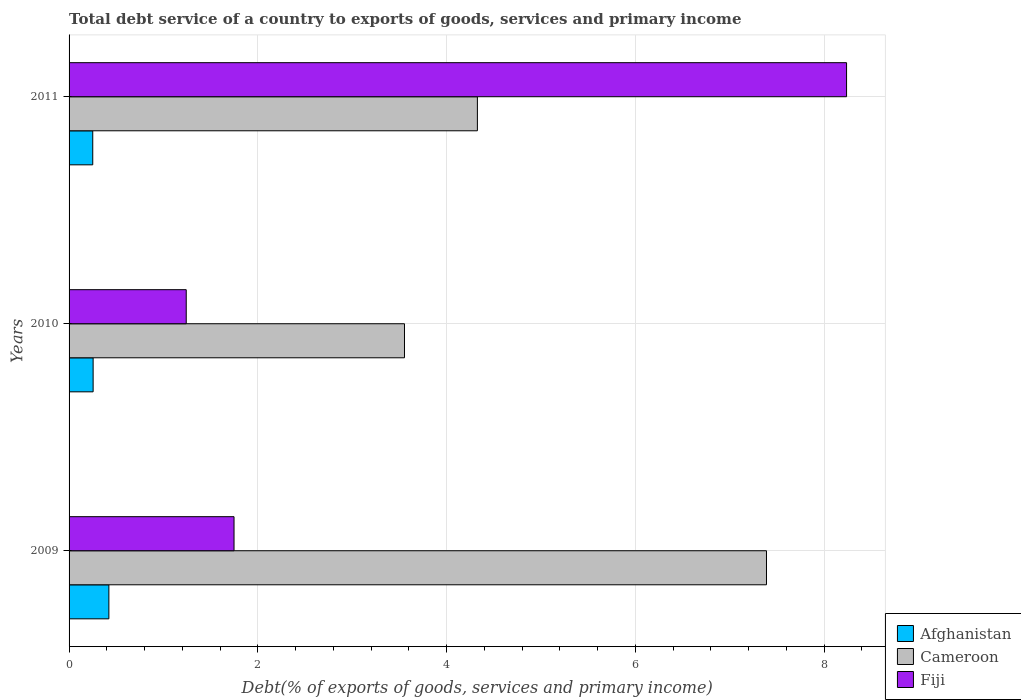How many different coloured bars are there?
Give a very brief answer. 3. Are the number of bars on each tick of the Y-axis equal?
Offer a very short reply. Yes. How many bars are there on the 3rd tick from the top?
Offer a terse response. 3. How many bars are there on the 2nd tick from the bottom?
Keep it short and to the point. 3. In how many cases, is the number of bars for a given year not equal to the number of legend labels?
Provide a succinct answer. 0. What is the total debt service in Fiji in 2009?
Make the answer very short. 1.75. Across all years, what is the maximum total debt service in Afghanistan?
Provide a short and direct response. 0.42. Across all years, what is the minimum total debt service in Fiji?
Give a very brief answer. 1.24. In which year was the total debt service in Cameroon maximum?
Ensure brevity in your answer.  2009. In which year was the total debt service in Afghanistan minimum?
Keep it short and to the point. 2011. What is the total total debt service in Afghanistan in the graph?
Your answer should be very brief. 0.93. What is the difference between the total debt service in Cameroon in 2009 and that in 2010?
Offer a very short reply. 3.84. What is the difference between the total debt service in Fiji in 2009 and the total debt service in Afghanistan in 2011?
Your answer should be compact. 1.5. What is the average total debt service in Afghanistan per year?
Your answer should be very brief. 0.31. In the year 2010, what is the difference between the total debt service in Cameroon and total debt service in Afghanistan?
Your answer should be compact. 3.3. What is the ratio of the total debt service in Fiji in 2009 to that in 2010?
Your answer should be compact. 1.41. Is the total debt service in Afghanistan in 2009 less than that in 2011?
Keep it short and to the point. No. Is the difference between the total debt service in Cameroon in 2010 and 2011 greater than the difference between the total debt service in Afghanistan in 2010 and 2011?
Offer a very short reply. No. What is the difference between the highest and the second highest total debt service in Cameroon?
Provide a succinct answer. 3.06. What is the difference between the highest and the lowest total debt service in Cameroon?
Give a very brief answer. 3.84. Is the sum of the total debt service in Afghanistan in 2009 and 2010 greater than the maximum total debt service in Fiji across all years?
Provide a succinct answer. No. What does the 3rd bar from the top in 2009 represents?
Provide a short and direct response. Afghanistan. What does the 2nd bar from the bottom in 2011 represents?
Your answer should be very brief. Cameroon. Is it the case that in every year, the sum of the total debt service in Cameroon and total debt service in Afghanistan is greater than the total debt service in Fiji?
Give a very brief answer. No. Are all the bars in the graph horizontal?
Your answer should be compact. Yes. What is the difference between two consecutive major ticks on the X-axis?
Your response must be concise. 2. Are the values on the major ticks of X-axis written in scientific E-notation?
Offer a very short reply. No. Does the graph contain any zero values?
Give a very brief answer. No. Does the graph contain grids?
Offer a very short reply. Yes. Where does the legend appear in the graph?
Ensure brevity in your answer.  Bottom right. What is the title of the graph?
Offer a very short reply. Total debt service of a country to exports of goods, services and primary income. Does "Samoa" appear as one of the legend labels in the graph?
Give a very brief answer. No. What is the label or title of the X-axis?
Provide a short and direct response. Debt(% of exports of goods, services and primary income). What is the label or title of the Y-axis?
Keep it short and to the point. Years. What is the Debt(% of exports of goods, services and primary income) of Afghanistan in 2009?
Provide a short and direct response. 0.42. What is the Debt(% of exports of goods, services and primary income) of Cameroon in 2009?
Offer a terse response. 7.39. What is the Debt(% of exports of goods, services and primary income) of Fiji in 2009?
Offer a very short reply. 1.75. What is the Debt(% of exports of goods, services and primary income) in Afghanistan in 2010?
Ensure brevity in your answer.  0.25. What is the Debt(% of exports of goods, services and primary income) in Cameroon in 2010?
Give a very brief answer. 3.55. What is the Debt(% of exports of goods, services and primary income) of Fiji in 2010?
Ensure brevity in your answer.  1.24. What is the Debt(% of exports of goods, services and primary income) of Afghanistan in 2011?
Your answer should be compact. 0.25. What is the Debt(% of exports of goods, services and primary income) of Cameroon in 2011?
Provide a succinct answer. 4.33. What is the Debt(% of exports of goods, services and primary income) in Fiji in 2011?
Offer a terse response. 8.24. Across all years, what is the maximum Debt(% of exports of goods, services and primary income) in Afghanistan?
Offer a terse response. 0.42. Across all years, what is the maximum Debt(% of exports of goods, services and primary income) in Cameroon?
Your answer should be compact. 7.39. Across all years, what is the maximum Debt(% of exports of goods, services and primary income) of Fiji?
Ensure brevity in your answer.  8.24. Across all years, what is the minimum Debt(% of exports of goods, services and primary income) of Afghanistan?
Offer a terse response. 0.25. Across all years, what is the minimum Debt(% of exports of goods, services and primary income) in Cameroon?
Offer a terse response. 3.55. Across all years, what is the minimum Debt(% of exports of goods, services and primary income) of Fiji?
Offer a very short reply. 1.24. What is the total Debt(% of exports of goods, services and primary income) of Afghanistan in the graph?
Offer a very short reply. 0.93. What is the total Debt(% of exports of goods, services and primary income) of Cameroon in the graph?
Provide a succinct answer. 15.27. What is the total Debt(% of exports of goods, services and primary income) in Fiji in the graph?
Your answer should be compact. 11.23. What is the difference between the Debt(% of exports of goods, services and primary income) of Afghanistan in 2009 and that in 2010?
Your answer should be very brief. 0.17. What is the difference between the Debt(% of exports of goods, services and primary income) of Cameroon in 2009 and that in 2010?
Your answer should be compact. 3.84. What is the difference between the Debt(% of exports of goods, services and primary income) of Fiji in 2009 and that in 2010?
Make the answer very short. 0.51. What is the difference between the Debt(% of exports of goods, services and primary income) in Afghanistan in 2009 and that in 2011?
Give a very brief answer. 0.17. What is the difference between the Debt(% of exports of goods, services and primary income) of Cameroon in 2009 and that in 2011?
Ensure brevity in your answer.  3.06. What is the difference between the Debt(% of exports of goods, services and primary income) of Fiji in 2009 and that in 2011?
Provide a short and direct response. -6.49. What is the difference between the Debt(% of exports of goods, services and primary income) in Afghanistan in 2010 and that in 2011?
Keep it short and to the point. 0. What is the difference between the Debt(% of exports of goods, services and primary income) in Cameroon in 2010 and that in 2011?
Your response must be concise. -0.77. What is the difference between the Debt(% of exports of goods, services and primary income) of Fiji in 2010 and that in 2011?
Provide a short and direct response. -7. What is the difference between the Debt(% of exports of goods, services and primary income) in Afghanistan in 2009 and the Debt(% of exports of goods, services and primary income) in Cameroon in 2010?
Provide a short and direct response. -3.13. What is the difference between the Debt(% of exports of goods, services and primary income) of Afghanistan in 2009 and the Debt(% of exports of goods, services and primary income) of Fiji in 2010?
Provide a succinct answer. -0.82. What is the difference between the Debt(% of exports of goods, services and primary income) of Cameroon in 2009 and the Debt(% of exports of goods, services and primary income) of Fiji in 2010?
Make the answer very short. 6.15. What is the difference between the Debt(% of exports of goods, services and primary income) of Afghanistan in 2009 and the Debt(% of exports of goods, services and primary income) of Cameroon in 2011?
Offer a terse response. -3.9. What is the difference between the Debt(% of exports of goods, services and primary income) in Afghanistan in 2009 and the Debt(% of exports of goods, services and primary income) in Fiji in 2011?
Keep it short and to the point. -7.82. What is the difference between the Debt(% of exports of goods, services and primary income) of Cameroon in 2009 and the Debt(% of exports of goods, services and primary income) of Fiji in 2011?
Ensure brevity in your answer.  -0.85. What is the difference between the Debt(% of exports of goods, services and primary income) of Afghanistan in 2010 and the Debt(% of exports of goods, services and primary income) of Cameroon in 2011?
Your response must be concise. -4.07. What is the difference between the Debt(% of exports of goods, services and primary income) of Afghanistan in 2010 and the Debt(% of exports of goods, services and primary income) of Fiji in 2011?
Keep it short and to the point. -7.98. What is the difference between the Debt(% of exports of goods, services and primary income) of Cameroon in 2010 and the Debt(% of exports of goods, services and primary income) of Fiji in 2011?
Ensure brevity in your answer.  -4.68. What is the average Debt(% of exports of goods, services and primary income) of Afghanistan per year?
Ensure brevity in your answer.  0.31. What is the average Debt(% of exports of goods, services and primary income) of Cameroon per year?
Provide a succinct answer. 5.09. What is the average Debt(% of exports of goods, services and primary income) in Fiji per year?
Provide a succinct answer. 3.74. In the year 2009, what is the difference between the Debt(% of exports of goods, services and primary income) of Afghanistan and Debt(% of exports of goods, services and primary income) of Cameroon?
Provide a succinct answer. -6.97. In the year 2009, what is the difference between the Debt(% of exports of goods, services and primary income) of Afghanistan and Debt(% of exports of goods, services and primary income) of Fiji?
Keep it short and to the point. -1.33. In the year 2009, what is the difference between the Debt(% of exports of goods, services and primary income) in Cameroon and Debt(% of exports of goods, services and primary income) in Fiji?
Give a very brief answer. 5.64. In the year 2010, what is the difference between the Debt(% of exports of goods, services and primary income) in Afghanistan and Debt(% of exports of goods, services and primary income) in Cameroon?
Offer a very short reply. -3.3. In the year 2010, what is the difference between the Debt(% of exports of goods, services and primary income) in Afghanistan and Debt(% of exports of goods, services and primary income) in Fiji?
Your answer should be very brief. -0.99. In the year 2010, what is the difference between the Debt(% of exports of goods, services and primary income) of Cameroon and Debt(% of exports of goods, services and primary income) of Fiji?
Ensure brevity in your answer.  2.31. In the year 2011, what is the difference between the Debt(% of exports of goods, services and primary income) of Afghanistan and Debt(% of exports of goods, services and primary income) of Cameroon?
Make the answer very short. -4.08. In the year 2011, what is the difference between the Debt(% of exports of goods, services and primary income) of Afghanistan and Debt(% of exports of goods, services and primary income) of Fiji?
Ensure brevity in your answer.  -7.99. In the year 2011, what is the difference between the Debt(% of exports of goods, services and primary income) in Cameroon and Debt(% of exports of goods, services and primary income) in Fiji?
Your response must be concise. -3.91. What is the ratio of the Debt(% of exports of goods, services and primary income) in Afghanistan in 2009 to that in 2010?
Your answer should be compact. 1.65. What is the ratio of the Debt(% of exports of goods, services and primary income) of Cameroon in 2009 to that in 2010?
Ensure brevity in your answer.  2.08. What is the ratio of the Debt(% of exports of goods, services and primary income) in Fiji in 2009 to that in 2010?
Ensure brevity in your answer.  1.41. What is the ratio of the Debt(% of exports of goods, services and primary income) in Afghanistan in 2009 to that in 2011?
Provide a succinct answer. 1.68. What is the ratio of the Debt(% of exports of goods, services and primary income) of Cameroon in 2009 to that in 2011?
Offer a terse response. 1.71. What is the ratio of the Debt(% of exports of goods, services and primary income) of Fiji in 2009 to that in 2011?
Ensure brevity in your answer.  0.21. What is the ratio of the Debt(% of exports of goods, services and primary income) of Afghanistan in 2010 to that in 2011?
Make the answer very short. 1.02. What is the ratio of the Debt(% of exports of goods, services and primary income) in Cameroon in 2010 to that in 2011?
Keep it short and to the point. 0.82. What is the ratio of the Debt(% of exports of goods, services and primary income) in Fiji in 2010 to that in 2011?
Your response must be concise. 0.15. What is the difference between the highest and the second highest Debt(% of exports of goods, services and primary income) in Afghanistan?
Make the answer very short. 0.17. What is the difference between the highest and the second highest Debt(% of exports of goods, services and primary income) in Cameroon?
Ensure brevity in your answer.  3.06. What is the difference between the highest and the second highest Debt(% of exports of goods, services and primary income) of Fiji?
Offer a terse response. 6.49. What is the difference between the highest and the lowest Debt(% of exports of goods, services and primary income) of Afghanistan?
Your answer should be very brief. 0.17. What is the difference between the highest and the lowest Debt(% of exports of goods, services and primary income) of Cameroon?
Provide a short and direct response. 3.84. What is the difference between the highest and the lowest Debt(% of exports of goods, services and primary income) in Fiji?
Your answer should be compact. 7. 